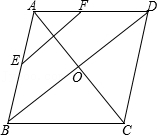Clarify your interpretation of the image. The image displays a geometric diagram featuring a diamond-shaped figure labeled ABCD. Points E and F are marked on the midpoints of the edges AB and AD, respectively. The diagram also includes additional geometric elements such as point O, which appears to be the intersection point of the diagonals of the diamond. This type of diagram is typically used in geometry to explore properties like symmetry, midpoint theorems, or relationships within a quadrilateral. 